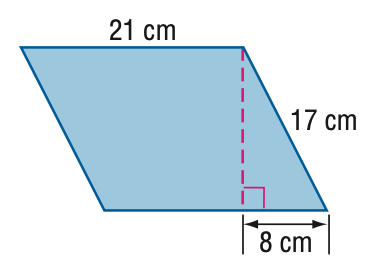Answer the mathemtical geometry problem and directly provide the correct option letter.
Question: Find the perimeter of the parallelogram.
Choices: A: 72 B: 74 C: 76 D: 78 C 